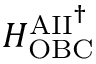<formula> <loc_0><loc_0><loc_500><loc_500>H _ { O B C } ^ { A I I ^ { \dag } }</formula> 